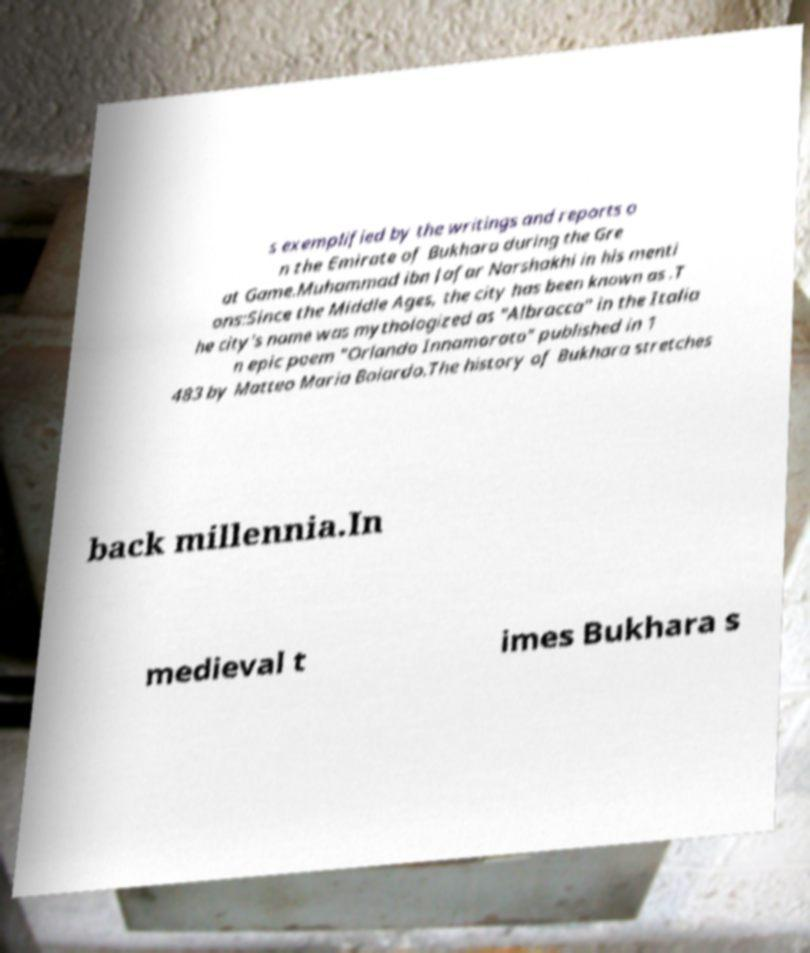Can you accurately transcribe the text from the provided image for me? s exemplified by the writings and reports o n the Emirate of Bukhara during the Gre at Game.Muhammad ibn Jafar Narshakhi in his menti ons:Since the Middle Ages, the city has been known as .T he city's name was mythologized as "Albracca" in the Italia n epic poem "Orlando Innamorato" published in 1 483 by Matteo Maria Boiardo.The history of Bukhara stretches back millennia.In medieval t imes Bukhara s 